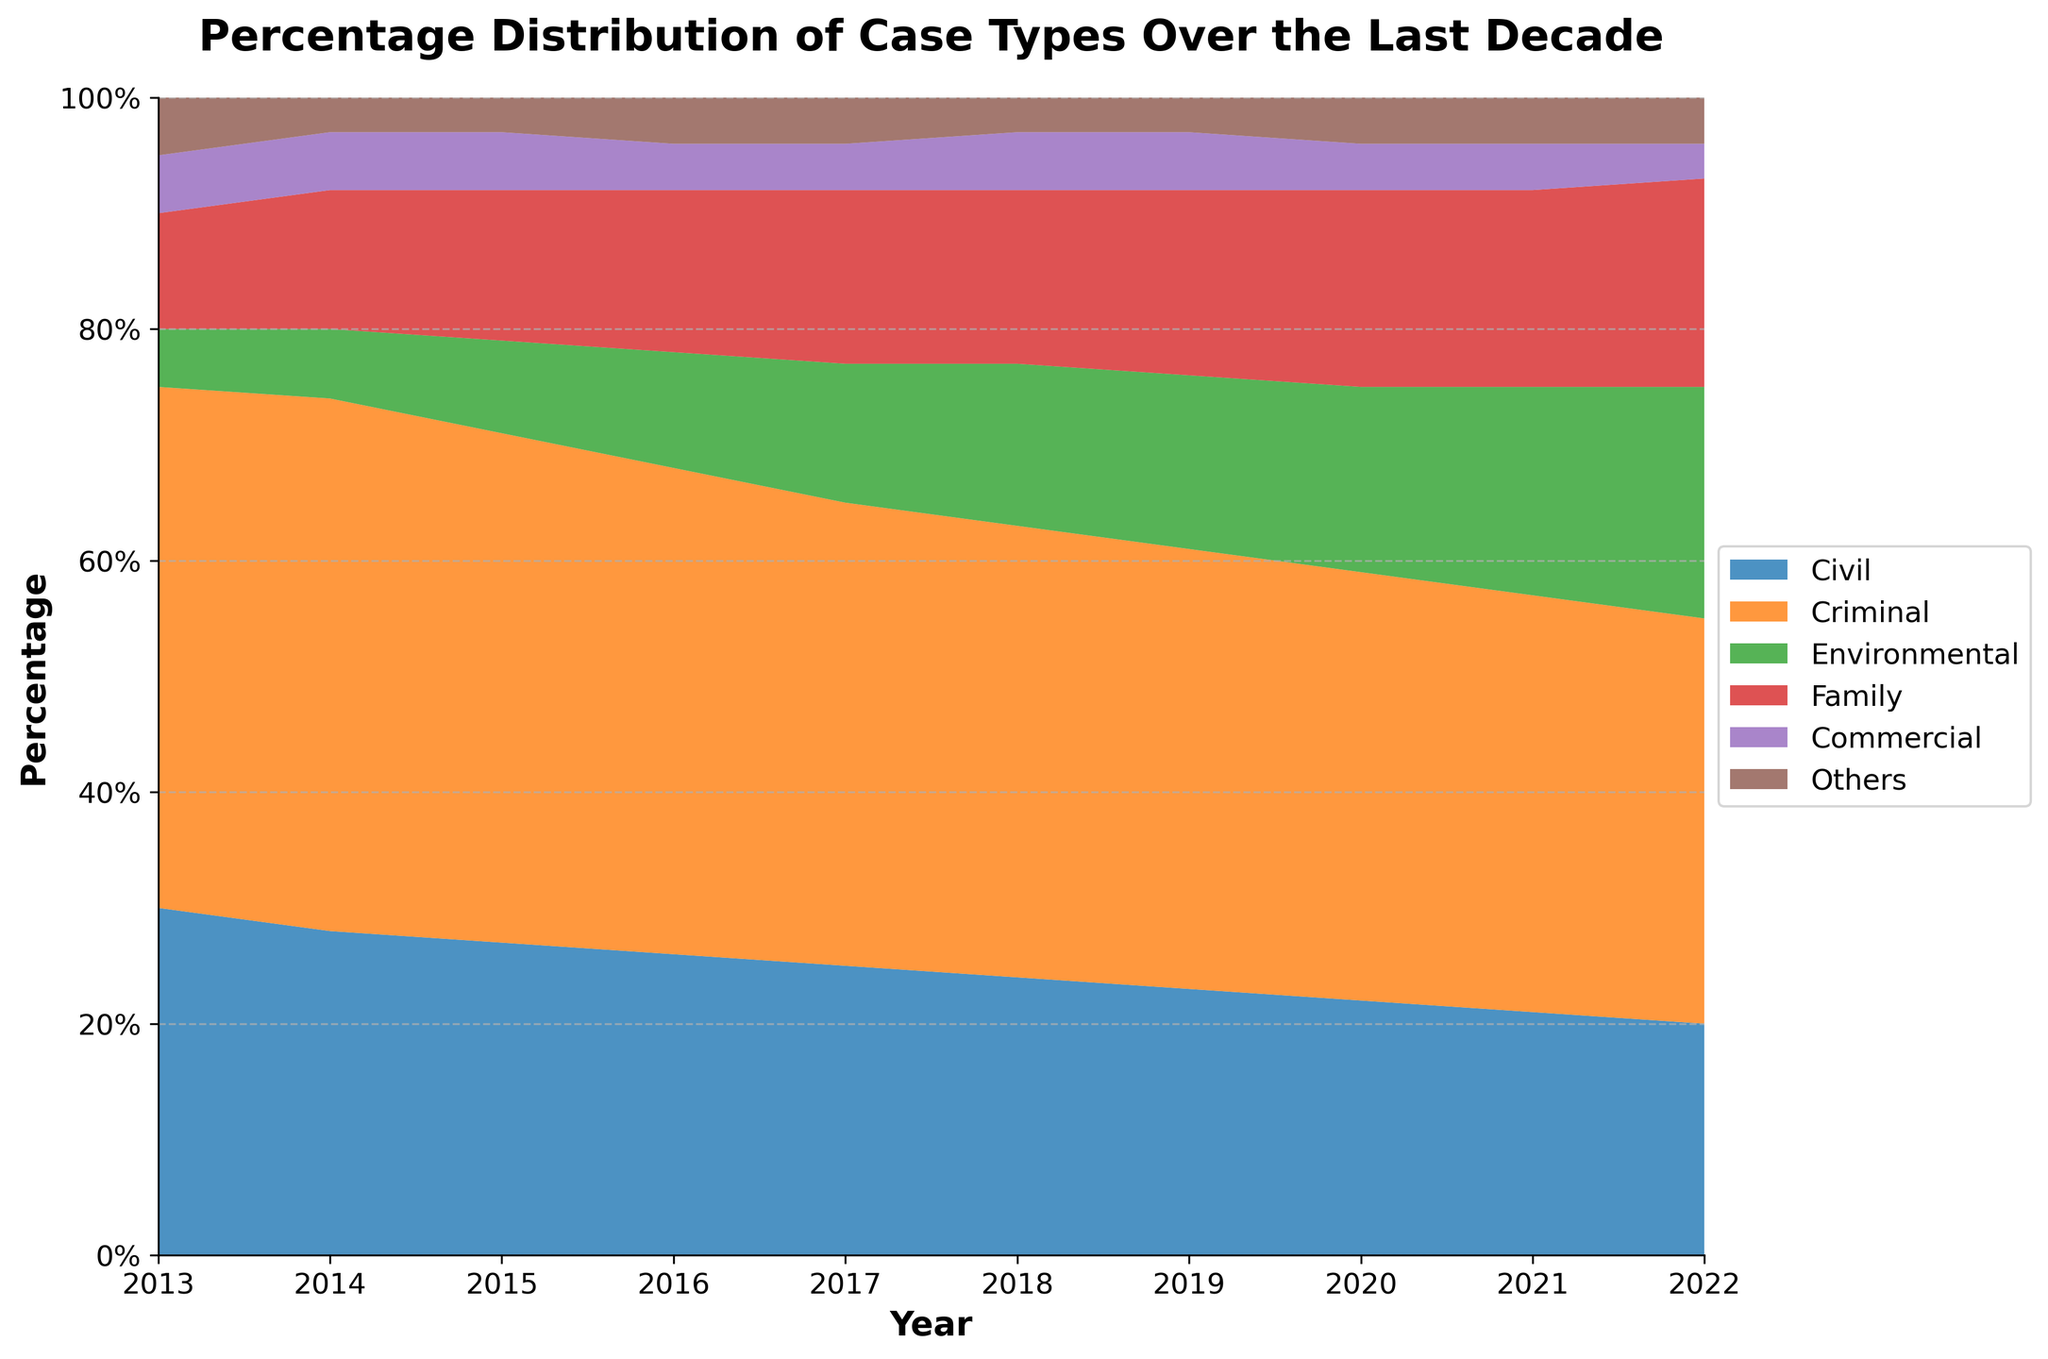What is the title of the chart? The title of the chart is located at the top and provides a summary of what the chart represents.
Answer: Percentage Distribution of Case Types Over the Last Decade What is the percentage of Criminal cases in 2019? Locate the value corresponding to Criminal cases in 2019 from the chart.
Answer: 38% Which case type increased the most between 2013 and 2022? Compare the initial and final values for each case type over the years. Environmental cases increased from 5% to 20%.
Answer: Environmental By how much did the share of Civil cases decrease from 2013 to 2022? Subtract the percentage of Civil cases in 2022 from the percentage in 2013. 30% - 20% = 10%.
Answer: 10% Which year did Family cases surpass 15%? Check the chart for the year where Family cases first exceed 15%.
Answer: 2019 What is the trend for Commercial cases over this period? Observe the changes in the area representing Commercial cases from 2013 to 2022. The percentage trend remained mostly consistent around 3%-5%.
Answer: Mostly stable How did the percentage share of Others change from 2013 to 2022? Compare the starting and ending percentages of the Others category over the given period. It remained approximately at 4-5%.
Answer: Relatively stable In which year did Environmental cases see the highest increase from the prior year? Identify the year-to-year changes in the Environmental category and find the largest increment. The significant increase was between 2016 and 2017, where it grew from 10% to 12%.
Answer: 2016 to 2017 What is the combined percentage of Family and Commercial cases in 2020? Add the percentages of Family and Commercial cases for the year 2020: 17% + 4% = 21%.
Answer: 21% In which year was the total percentage of Civil and Criminal cases lowest? Sum the percentages of both Civil and Criminal cases for each year and find the year with the lowest total. 2022 has 55% (20% Civil + 35% Criminal).
Answer: 2022 